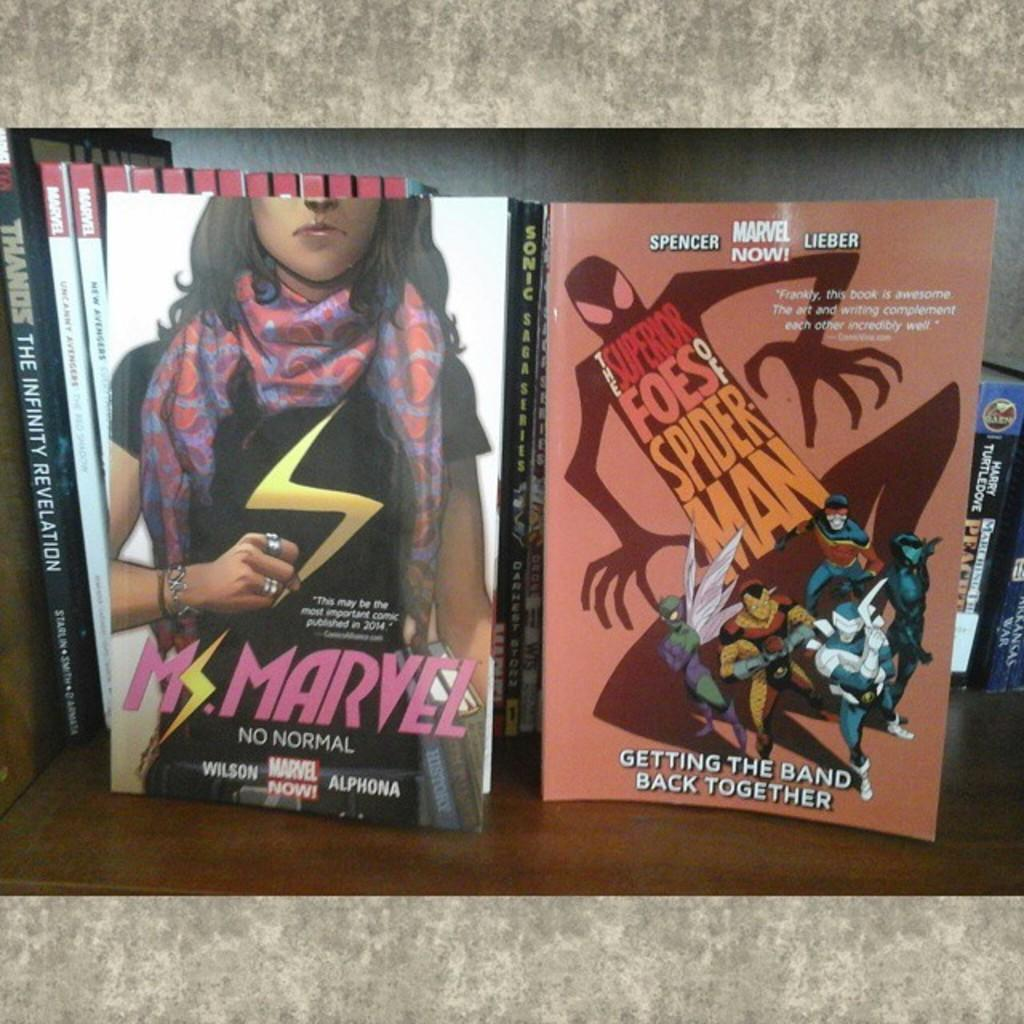<image>
Relay a brief, clear account of the picture shown. A book titled "Ms. Marvel" from Marvel Now comic. 